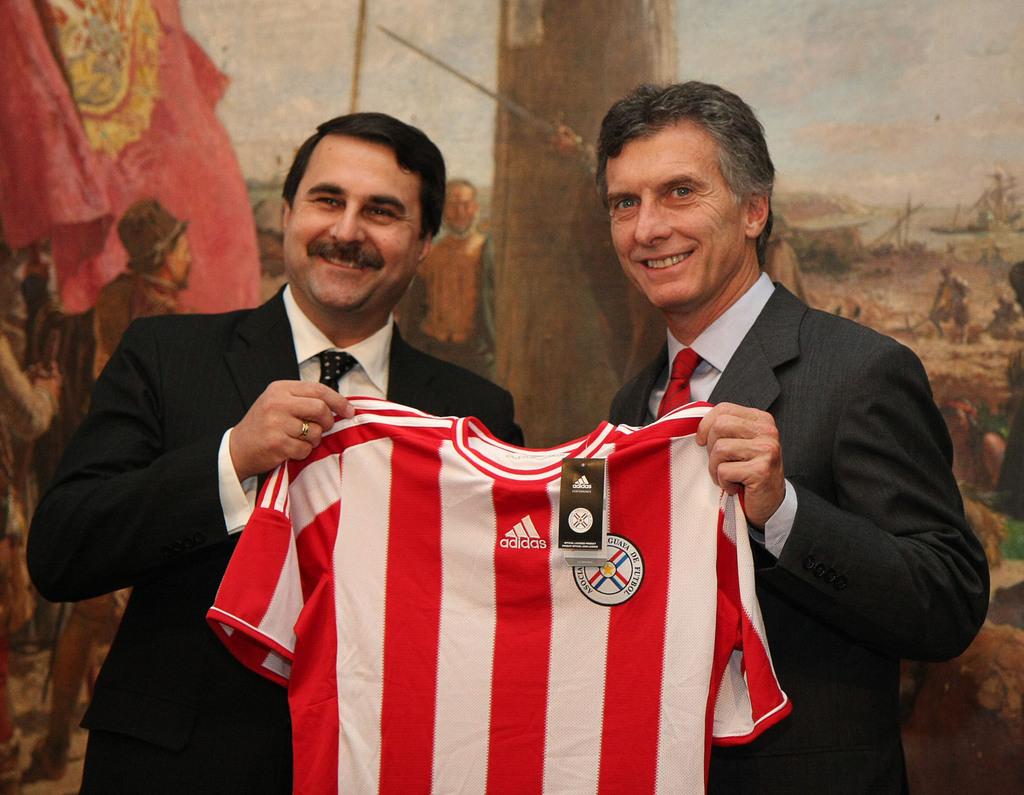What company manufacturers the shirt these men are holding?
Offer a terse response. Adidas. 